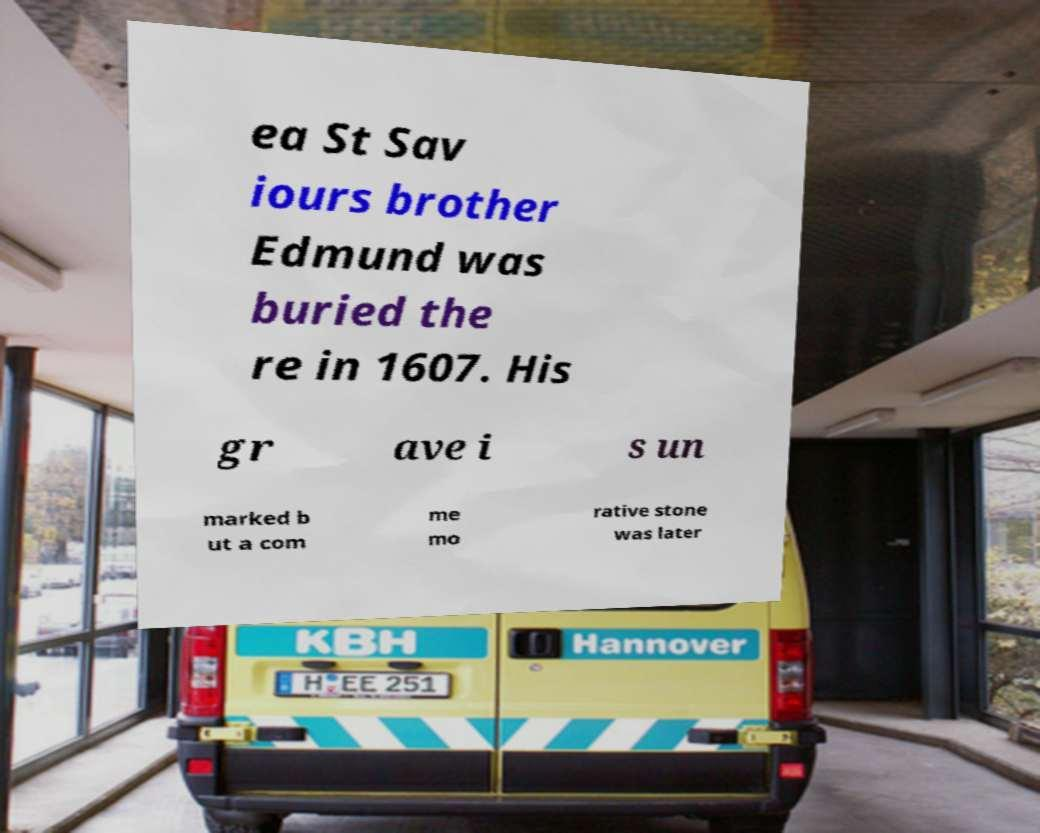Please identify and transcribe the text found in this image. ea St Sav iours brother Edmund was buried the re in 1607. His gr ave i s un marked b ut a com me mo rative stone was later 